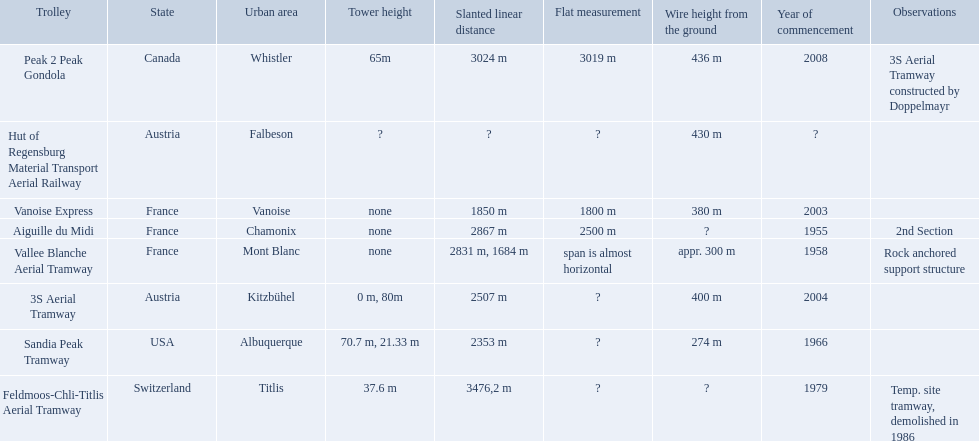Which tramways are in france? Vanoise Express, Aiguille du Midi, Vallee Blanche Aerial Tramway. Which of those were inaugurated in the 1950? Aiguille du Midi, Vallee Blanche Aerial Tramway. Which of these tramways span is not almost horizontal? Aiguille du Midi. What are all of the tramways? Peak 2 Peak Gondola, Hut of Regensburg Material Transport Aerial Railway, Vanoise Express, Aiguille du Midi, Vallee Blanche Aerial Tramway, 3S Aerial Tramway, Sandia Peak Tramway, Feldmoos-Chli-Titlis Aerial Tramway. When were they inaugurated? 2008, ?, 2003, 1955, 1958, 2004, 1966, 1979. Now, between 3s aerial tramway and aiguille du midi, which was inaugurated first? Aiguille du Midi. When was the aiguille du midi tramway inaugurated? 1955. When was the 3s aerial tramway inaugurated? 2004. Which one was inaugurated first? Aiguille du Midi. 